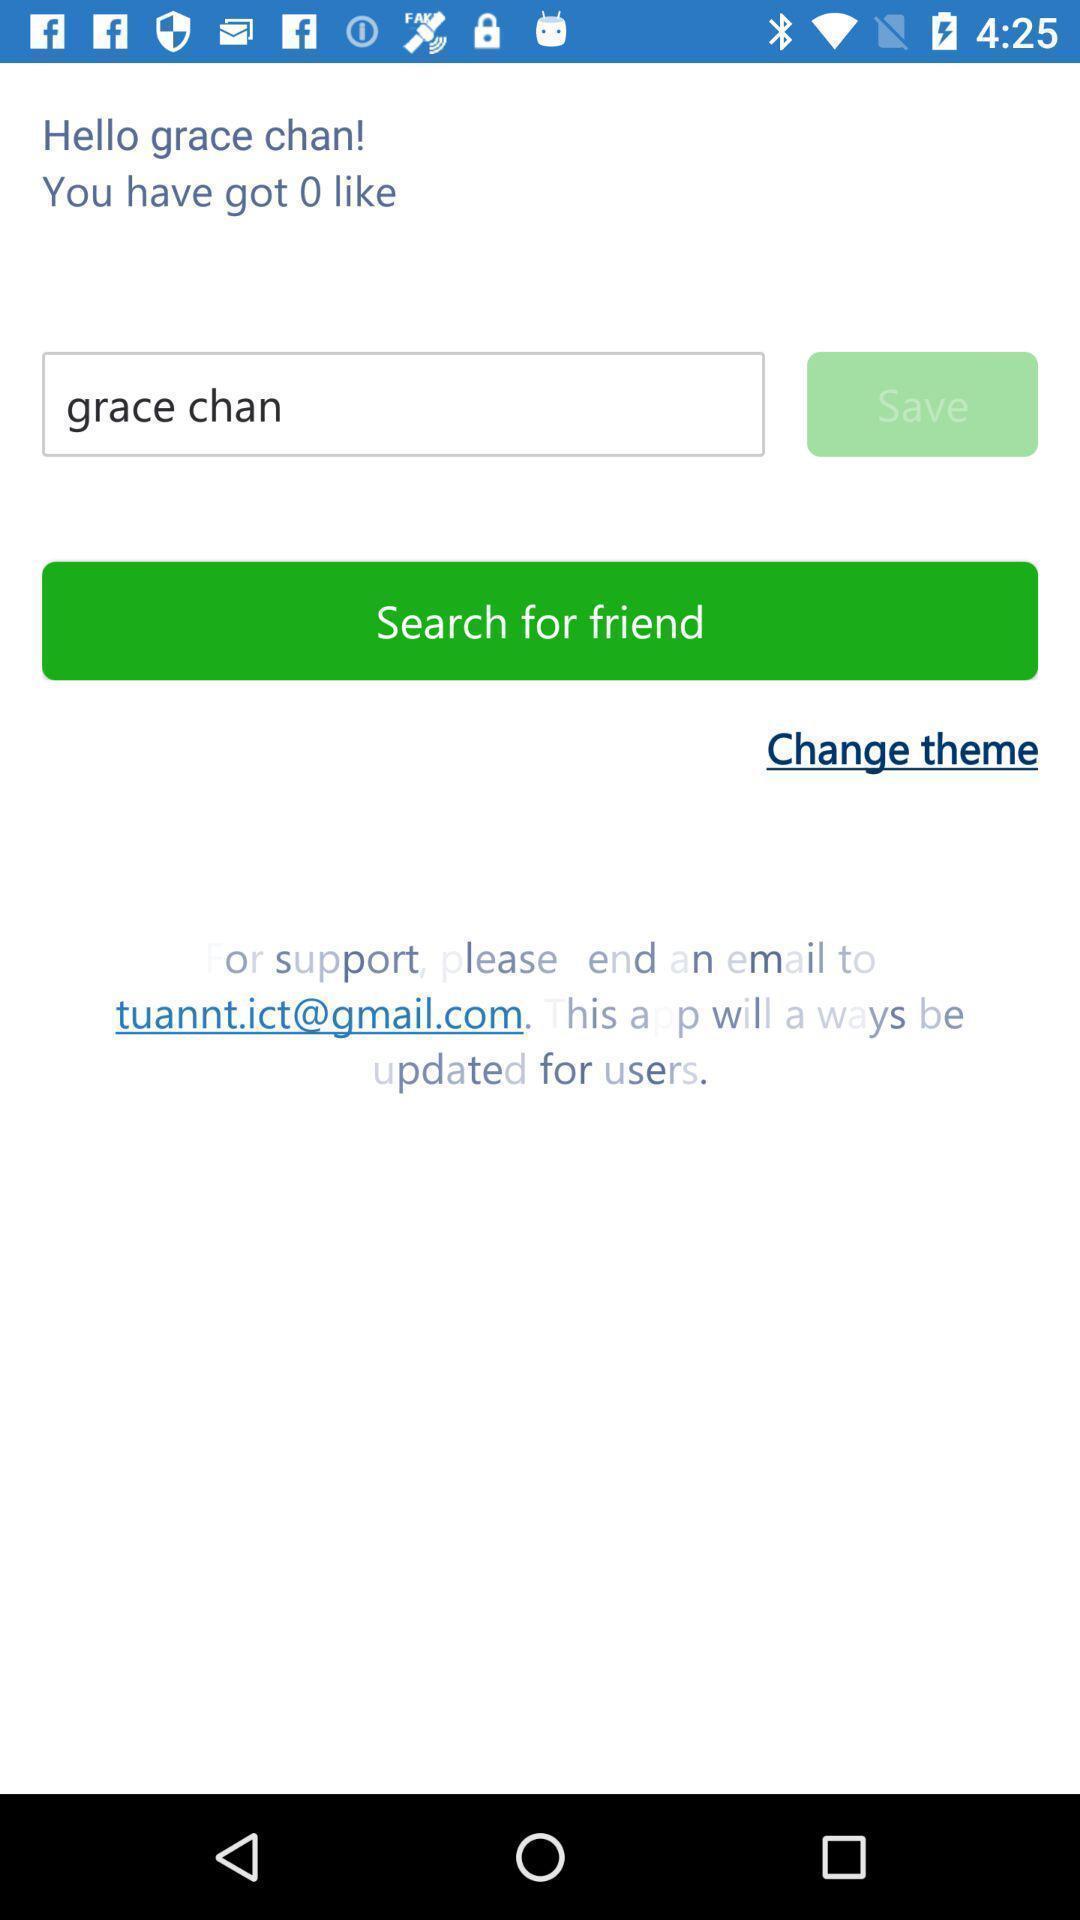Please provide a description for this image. Search for friend in the social app. 